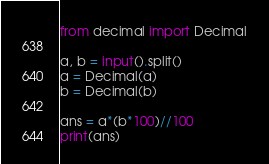<code> <loc_0><loc_0><loc_500><loc_500><_Python_>from decimal import Decimal

a, b = input().split()
a = Decimal(a)
b = Decimal(b)

ans = a*(b*100)//100
print(ans)</code> 